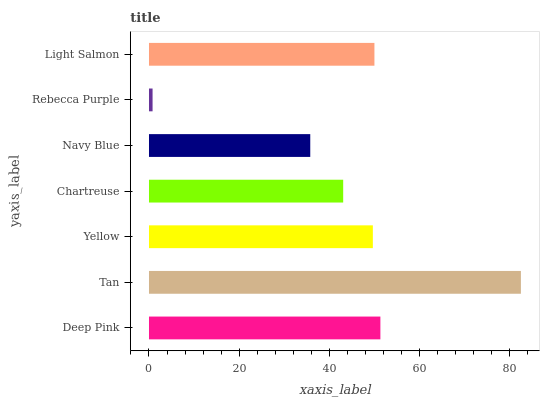Is Rebecca Purple the minimum?
Answer yes or no. Yes. Is Tan the maximum?
Answer yes or no. Yes. Is Yellow the minimum?
Answer yes or no. No. Is Yellow the maximum?
Answer yes or no. No. Is Tan greater than Yellow?
Answer yes or no. Yes. Is Yellow less than Tan?
Answer yes or no. Yes. Is Yellow greater than Tan?
Answer yes or no. No. Is Tan less than Yellow?
Answer yes or no. No. Is Yellow the high median?
Answer yes or no. Yes. Is Yellow the low median?
Answer yes or no. Yes. Is Navy Blue the high median?
Answer yes or no. No. Is Light Salmon the low median?
Answer yes or no. No. 